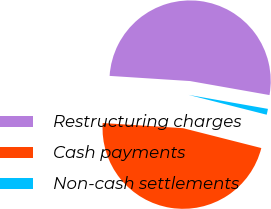Convert chart. <chart><loc_0><loc_0><loc_500><loc_500><pie_chart><fcel>Restructuring charges<fcel>Cash payments<fcel>Non-cash settlements<nl><fcel>51.76%<fcel>47.06%<fcel>1.18%<nl></chart> 